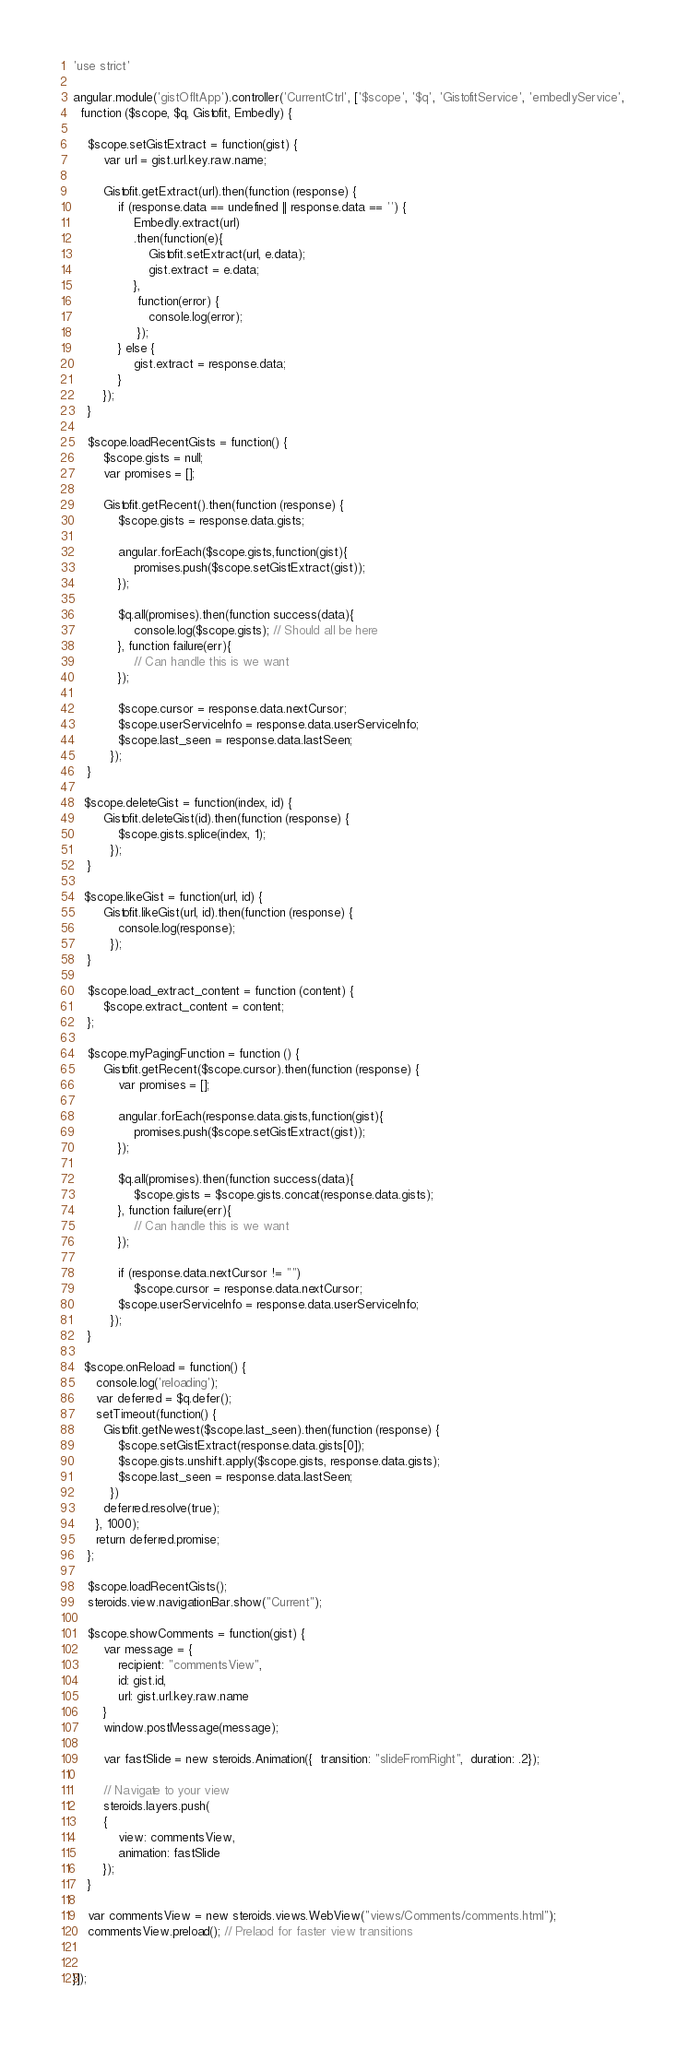<code> <loc_0><loc_0><loc_500><loc_500><_JavaScript_>'use strict'

angular.module('gistOfItApp').controller('CurrentCtrl', ['$scope', '$q', 'GistofitService', 'embedlyService', 
  function ($scope, $q, Gistofit, Embedly) {

    $scope.setGistExtract = function(gist) {
        var url = gist.url.key.raw.name;

        Gistofit.getExtract(url).then(function (response) {
            if (response.data == undefined || response.data == '') {
                Embedly.extract(url)
                .then(function(e){
                    Gistofit.setExtract(url, e.data);
                    gist.extract = e.data;
                },
                 function(error) {
                    console.log(error);
                 });
            } else {
                gist.extract = response.data;
            }
        });
    }

    $scope.loadRecentGists = function() {
        $scope.gists = null; 
        var promises = [];

        Gistofit.getRecent().then(function (response) {
            $scope.gists = response.data.gists;

            angular.forEach($scope.gists,function(gist){
                promises.push($scope.setGistExtract(gist));
            });

            $q.all(promises).then(function success(data){
                console.log($scope.gists); // Should all be here
            }, function failure(err){
                // Can handle this is we want
            });
            
            $scope.cursor = response.data.nextCursor; 
            $scope.userServiceInfo = response.data.userServiceInfo;
            $scope.last_seen = response.data.lastSeen;
          });
    }
   
   $scope.deleteGist = function(index, id) {
        Gistofit.deleteGist(id).then(function (response) {
            $scope.gists.splice(index, 1);
          });
    }
    
   $scope.likeGist = function(url, id) {
        Gistofit.likeGist(url, id).then(function (response) {
            console.log(response);
          });
    }

    $scope.load_extract_content = function (content) {
        $scope.extract_content = content;
    };

    $scope.myPagingFunction = function () {
        Gistofit.getRecent($scope.cursor).then(function (response) {
            var promises = [];
        
            angular.forEach(response.data.gists,function(gist){
                promises.push($scope.setGistExtract(gist));
            });

            $q.all(promises).then(function success(data){
                $scope.gists = $scope.gists.concat(response.data.gists); 
            }, function failure(err){
                // Can handle this is we want
            });
           
            if (response.data.nextCursor != "")
                $scope.cursor = response.data.nextCursor; 
            $scope.userServiceInfo = response.data.userServiceInfo;
          });
    }
   
   $scope.onReload = function() {
      console.log('reloading');
      var deferred = $q.defer();
      setTimeout(function() {
        Gistofit.getNewest($scope.last_seen).then(function (response) {
            $scope.setGistExtract(response.data.gists[0]);
            $scope.gists.unshift.apply($scope.gists, response.data.gists);
            $scope.last_seen = response.data.lastSeen;
          })
        deferred.resolve(true);
      }, 1000);
      return deferred.promise;
    };
    
    $scope.loadRecentGists();
    steroids.view.navigationBar.show("Current");

    $scope.showComments = function(gist) {
        var message = {
            recipient: "commentsView",
            id: gist.id,
            url: gist.url.key.raw.name
        }
        window.postMessage(message);
        
        var fastSlide = new steroids.Animation({  transition: "slideFromRight",  duration: .2});
        
        // Navigate to your view
        steroids.layers.push(
        {
            view: commentsView,
            animation: fastSlide 
        });
    }
    
    var commentsView = new steroids.views.WebView("views/Comments/comments.html");
    commentsView.preload(); // Prelaod for faster view transitions
   

}]);
</code> 